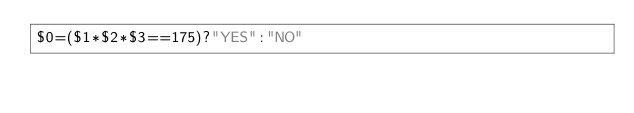<code> <loc_0><loc_0><loc_500><loc_500><_Awk_>$0=($1*$2*$3==175)?"YES":"NO"</code> 